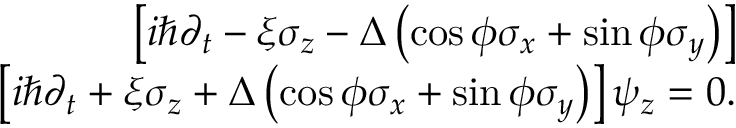<formula> <loc_0><loc_0><loc_500><loc_500>\begin{array} { r l r } & { \left [ i \hbar { \partial } _ { t } - \xi \sigma _ { z } - \Delta \left ( \cos \phi \sigma _ { x } + \sin \phi \sigma _ { y } \right ) \right ] } \\ & { \left [ i \hbar { \partial } _ { t } + \xi \sigma _ { z } + \Delta \left ( \cos \phi \sigma _ { x } + \sin \phi \sigma _ { y } \right ) \right ] \psi _ { z } = 0 . } \end{array}</formula> 